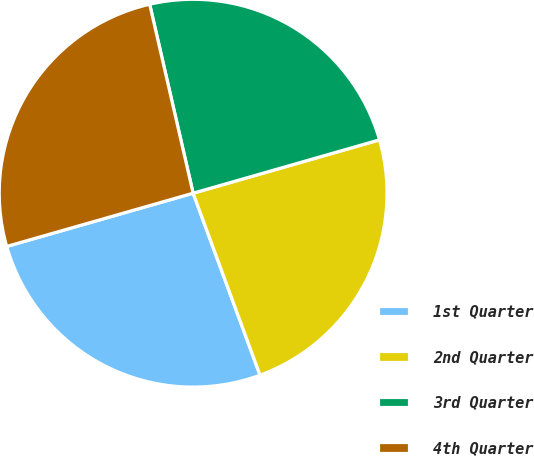<chart> <loc_0><loc_0><loc_500><loc_500><pie_chart><fcel>1st Quarter<fcel>2nd Quarter<fcel>3rd Quarter<fcel>4th Quarter<nl><fcel>26.18%<fcel>23.83%<fcel>24.16%<fcel>25.83%<nl></chart> 